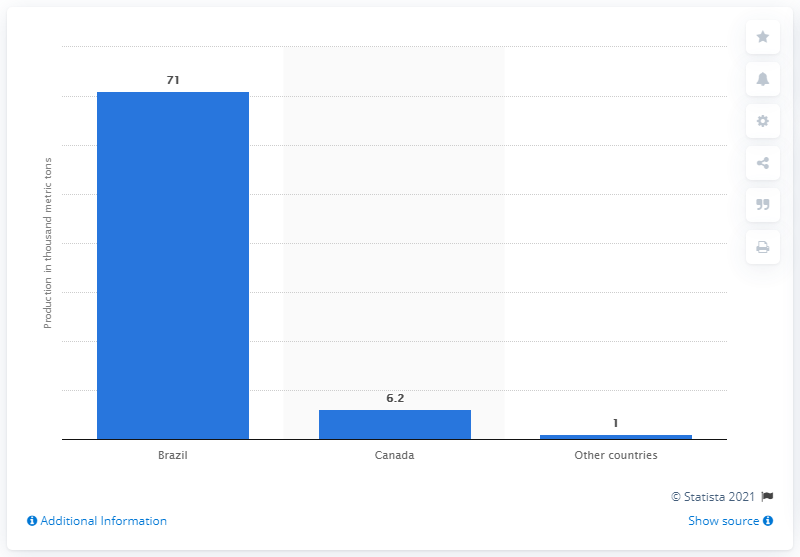Mention a couple of crucial points in this snapshot. Brazil was the largest producer of niobium in the world. 